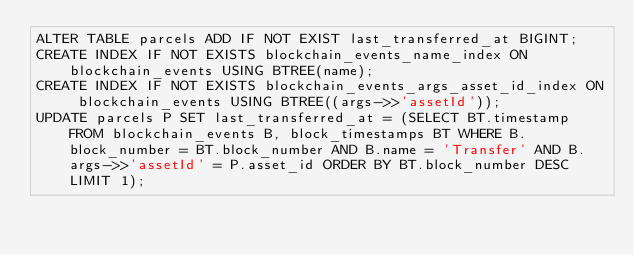Convert code to text. <code><loc_0><loc_0><loc_500><loc_500><_SQL_>ALTER TABLE parcels ADD IF NOT EXIST last_transferred_at BIGINT;
CREATE INDEX IF NOT EXISTS blockchain_events_name_index ON blockchain_events USING BTREE(name);
CREATE INDEX IF NOT EXISTS blockchain_events_args_asset_id_index ON blockchain_events USING BTREE((args->>'assetId'));
UPDATE parcels P SET last_transferred_at = (SELECT BT.timestamp FROM blockchain_events B, block_timestamps BT WHERE B.block_number = BT.block_number AND B.name = 'Transfer' AND B.args->>'assetId' = P.asset_id ORDER BY BT.block_number DESC LIMIT 1);
</code> 